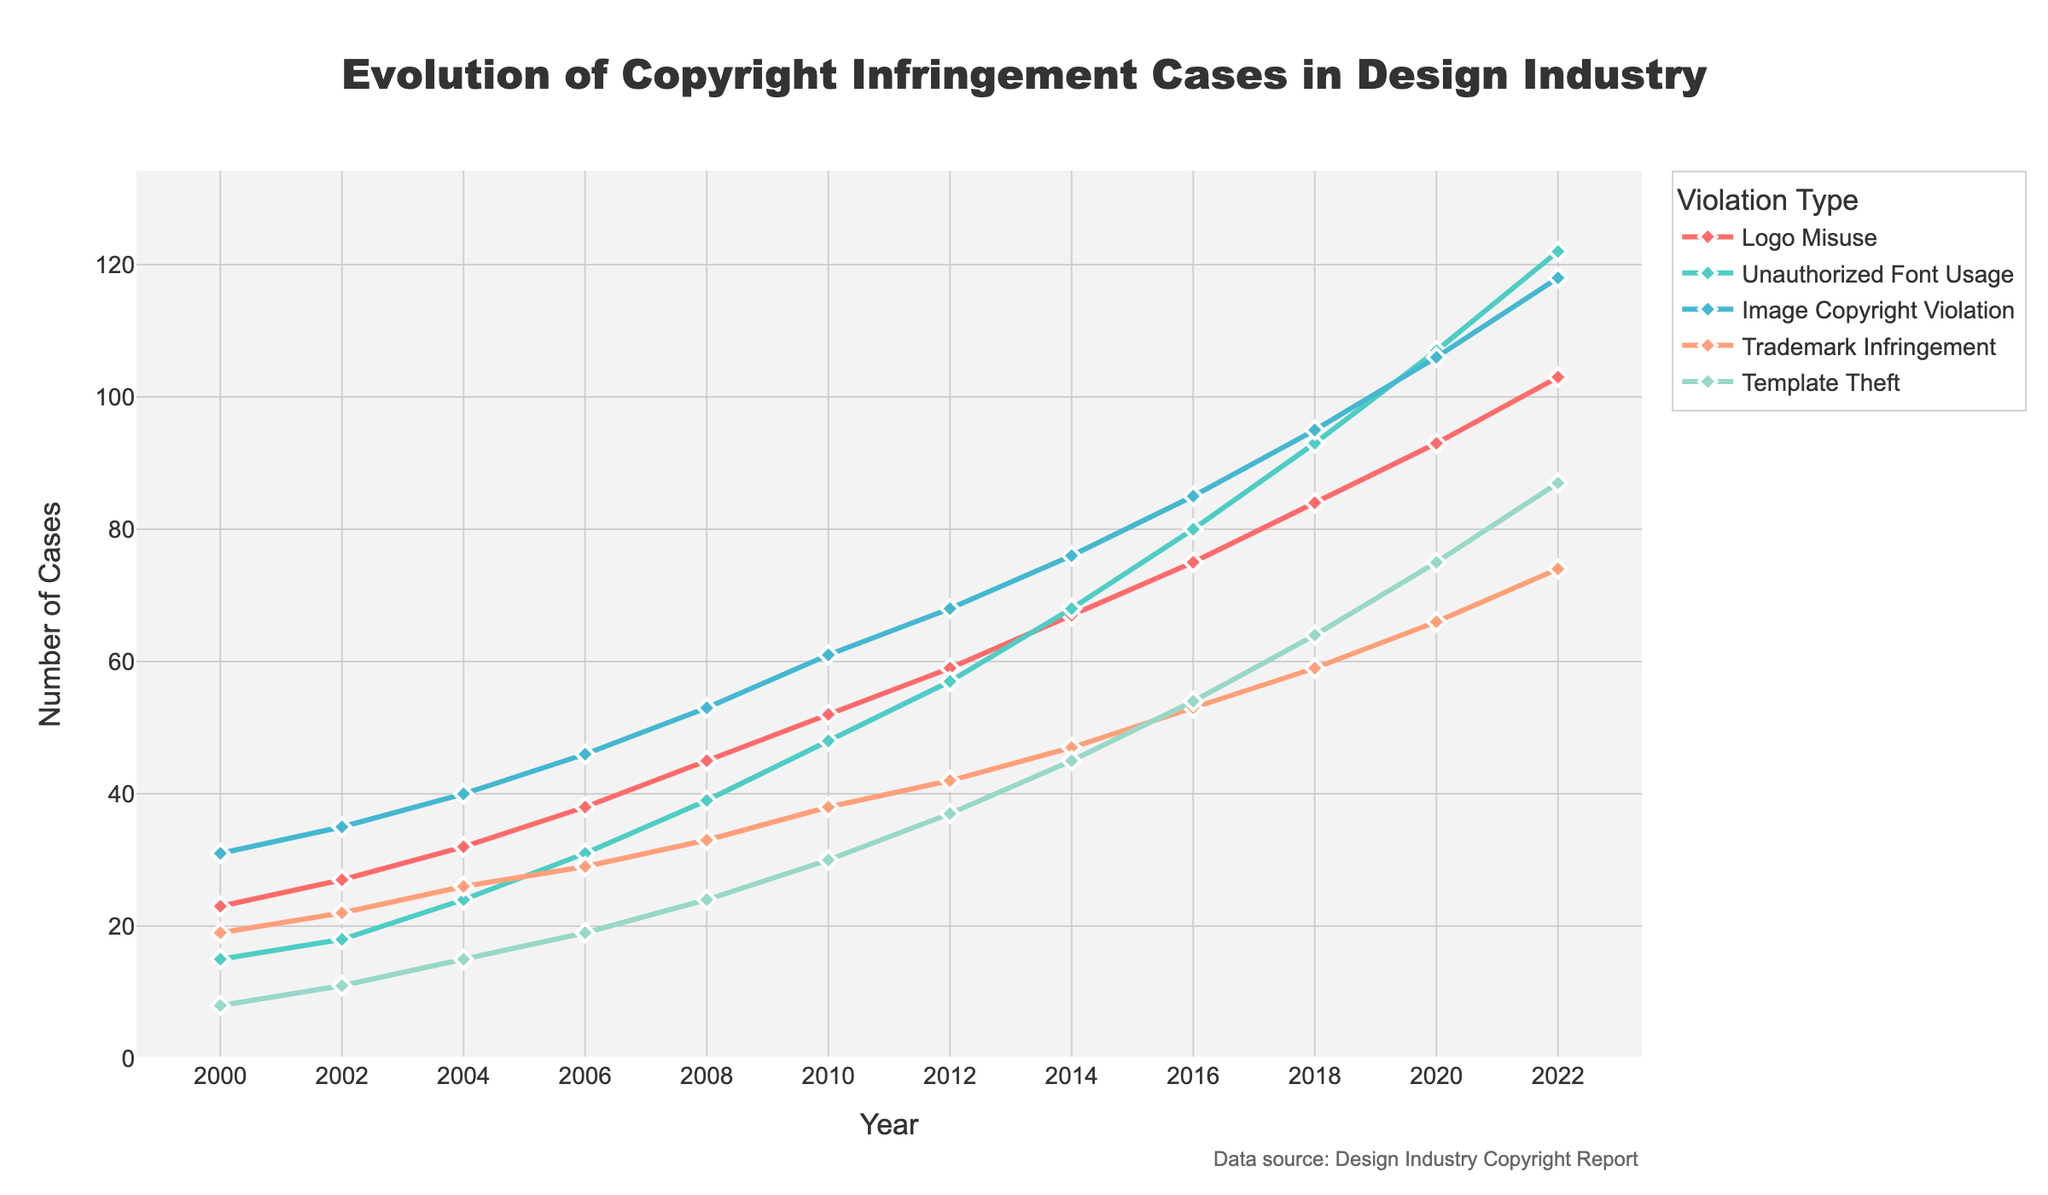What's the overall trend in Logo Misuse cases from 2000 to 2022? The number of Logo Misuse cases has been increasing steadily from 23 cases in 2000 to 103 cases in 2022, indicating an overall upward trend.
Answer: Increasing Which violation type had the highest number of cases in 2022? In 2022, Image Copyright Violation had the highest number of cases at 118, compared to the other violation types listed.
Answer: Image Copyright Violation Between which years did Trademark Infringement cases see the largest increase? By comparing the increments for each year gap, 2016 to 2018 showed the largest increase in Trademark Infringement cases, from 53 to 59, which is an increase of 6 cases.
Answer: 2016 to 2018 What is the difference in Unauthorized Font Usage cases between 2010 and 2020? In 2010, there were 48 cases of Unauthorized Font Usage, and in 2020, there were 107 cases. The difference is 107 - 48 = 59 cases.
Answer: 59 cases How does the growth rate of Template Theft cases compare from 2008 to 2010 versus 2020 to 2022? Between 2008 and 2010, Template Theft cases increased from 24 to 30, a change of 6. From 2020 to 2022, cases rose from 75 to 87, a change of 12. The growth rate was higher between 2020 and 2022.
Answer: Higher between 2020 and 2022 In which year did Unauthorized Font Usage cases surpass 80 for the first time? Unauthorized Font Usage cases surpassed 80 for the first time in 2016, reaching 80 cases that year.
Answer: 2016 Calculate the average number of cases for Image Copyright Violation in the even-numbered years between 2000 and 2022. Cases in even-numbered years are 2000: 31, 2002: 35, 2004: 40, 2006: 46, 2008: 53, 2010: 61, 2012: 68, 2014: 76, 2016: 85, 2018: 95, 2020: 106, 2022: 118. The sum is 814, and there are 12 data points, so the average is 814 / 12 ≈ 67.83.
Answer: ≈ 67.83 Identify which category had the most volatile trend and provide reasoning. Unauthorized Font Usage shows the most volatile trend, with the highest variations in increase. For example, the increase between 2016 and 2018 is much larger than earlier years. Such sharp rises are less evident in other categories.
Answer: Unauthorized Font Usage What's the ratio of Logo Misuse cases to Image Copyright Violation cases in 2022? In 2022, there were 103 Logo Misuse and 118 Image Copyright Violation cases. The ratio is 103 / 118 ≈ 0.873.
Answer: ≈ 0.873 